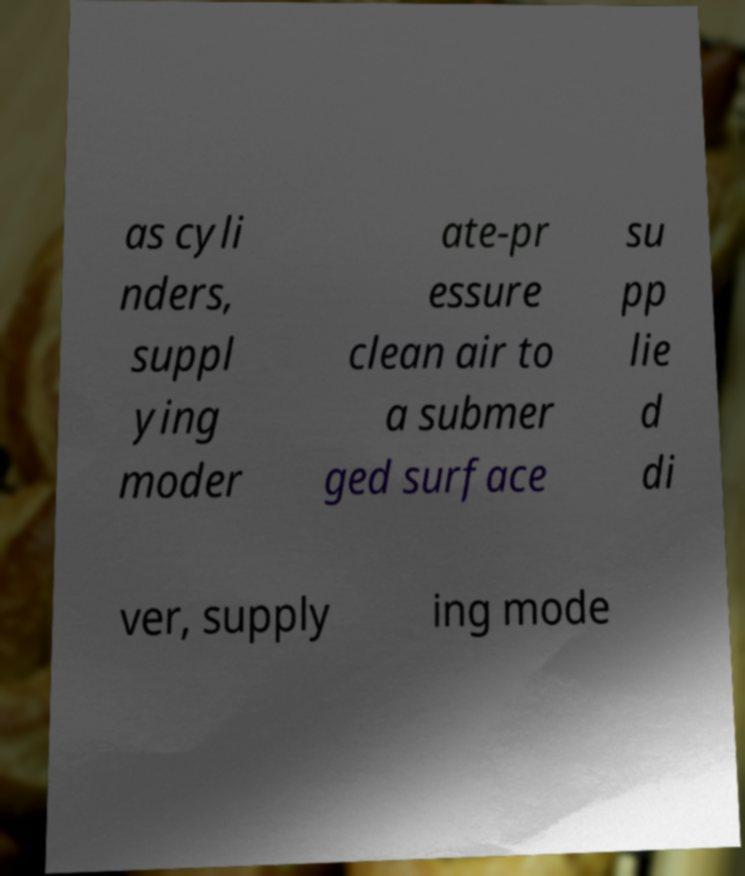There's text embedded in this image that I need extracted. Can you transcribe it verbatim? as cyli nders, suppl ying moder ate-pr essure clean air to a submer ged surface su pp lie d di ver, supply ing mode 